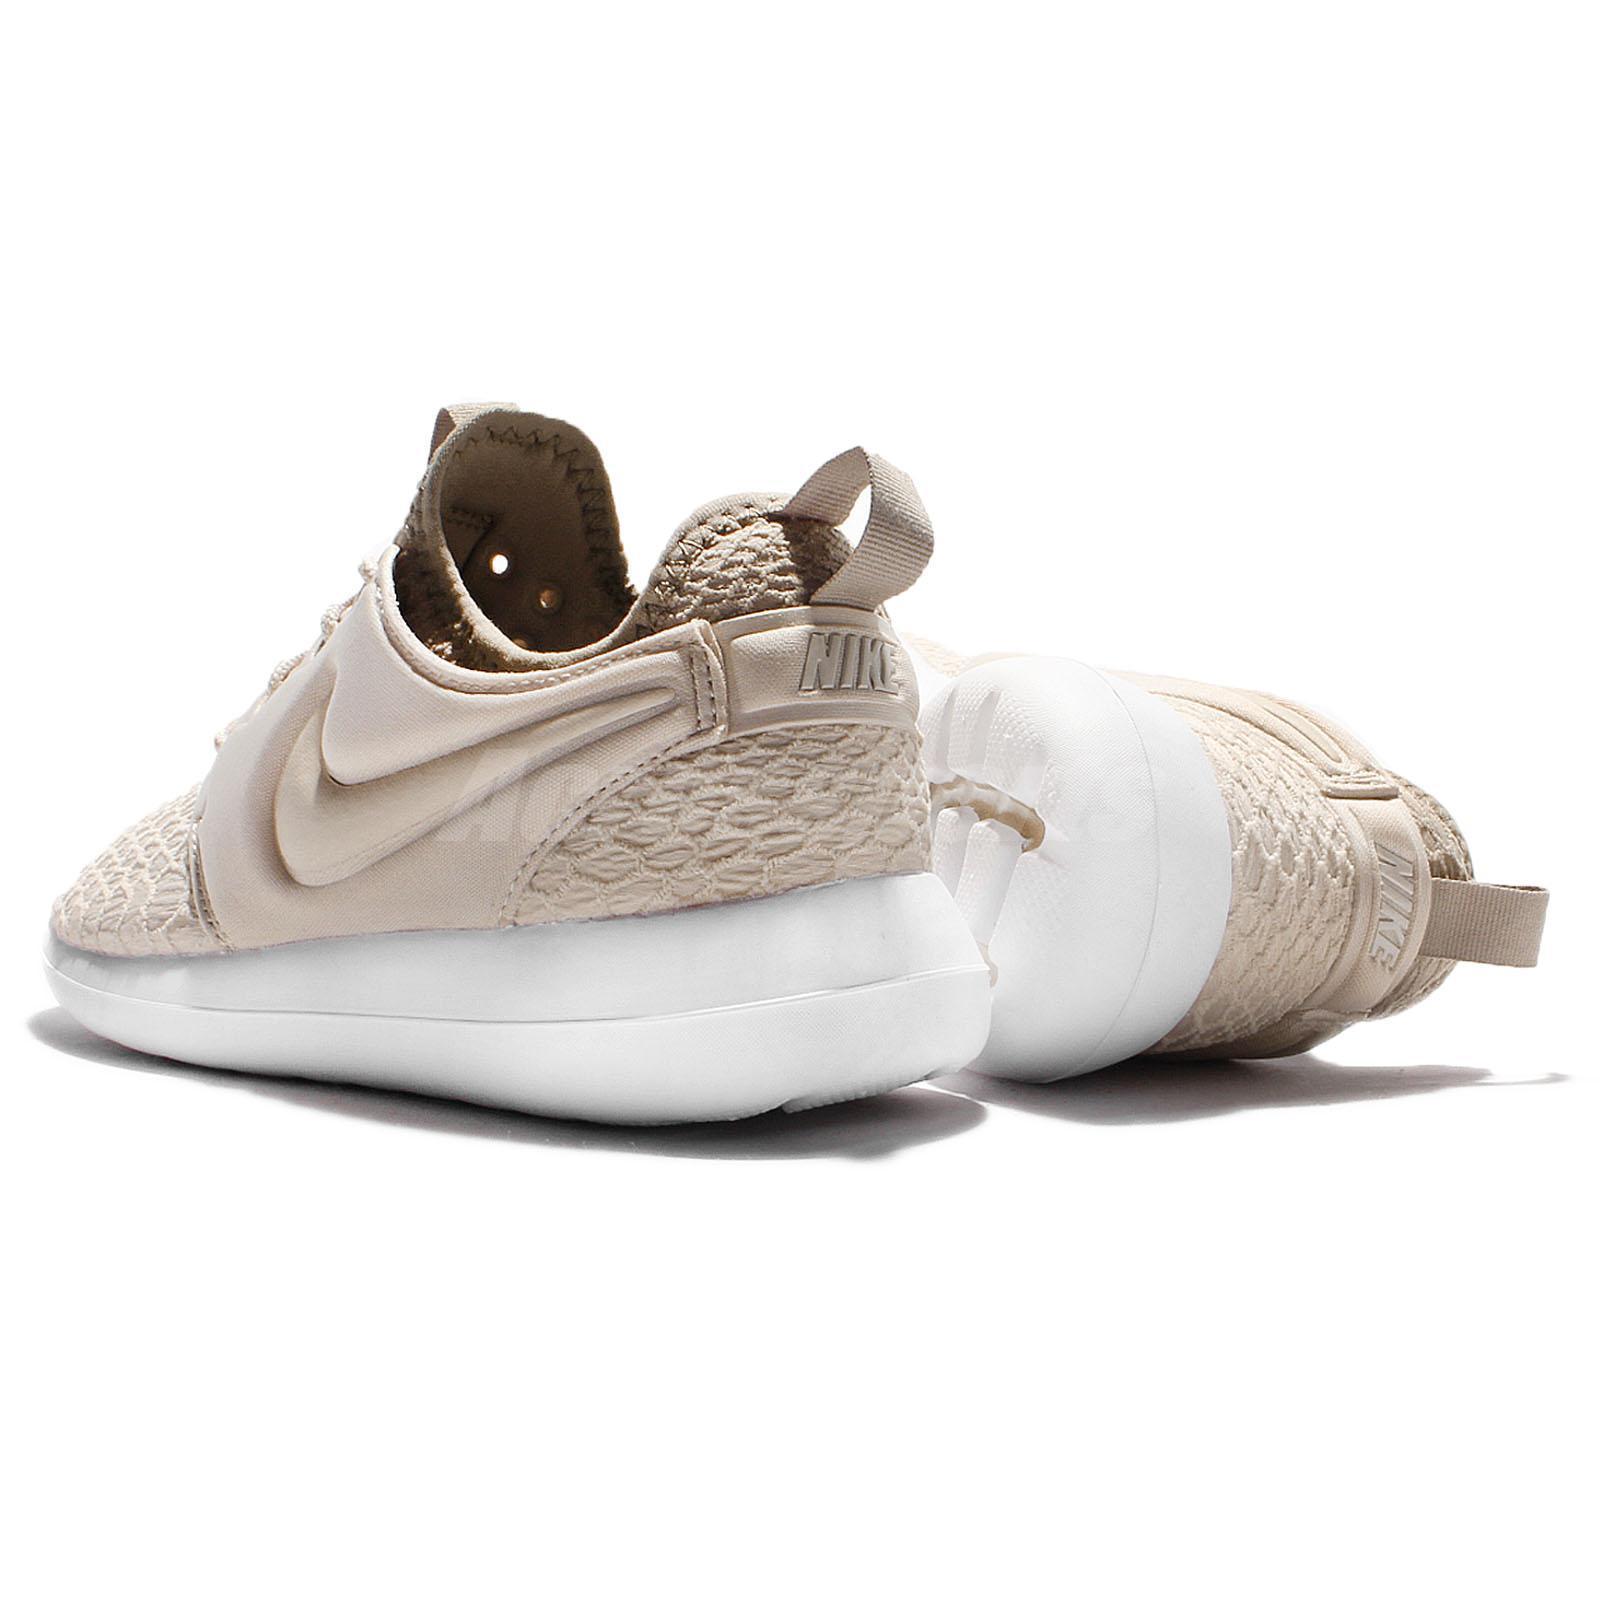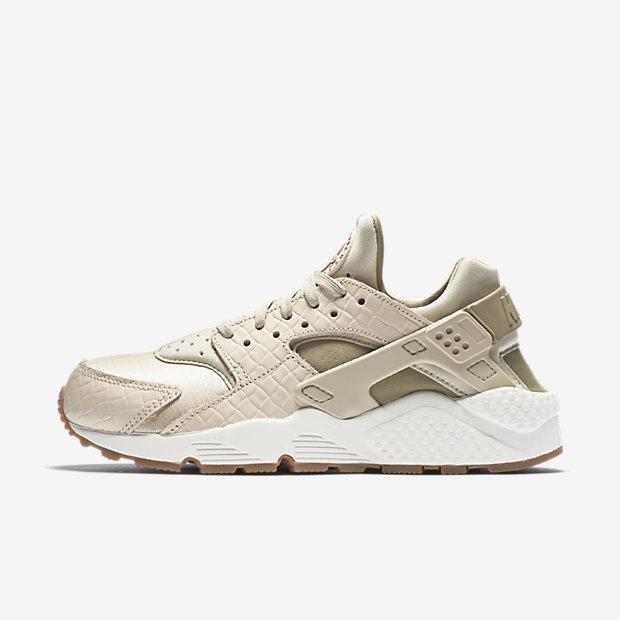The first image is the image on the left, the second image is the image on the right. Examine the images to the left and right. Is the description "The two shoes in the images are facing in opposite directions." accurate? Answer yes or no. No. 